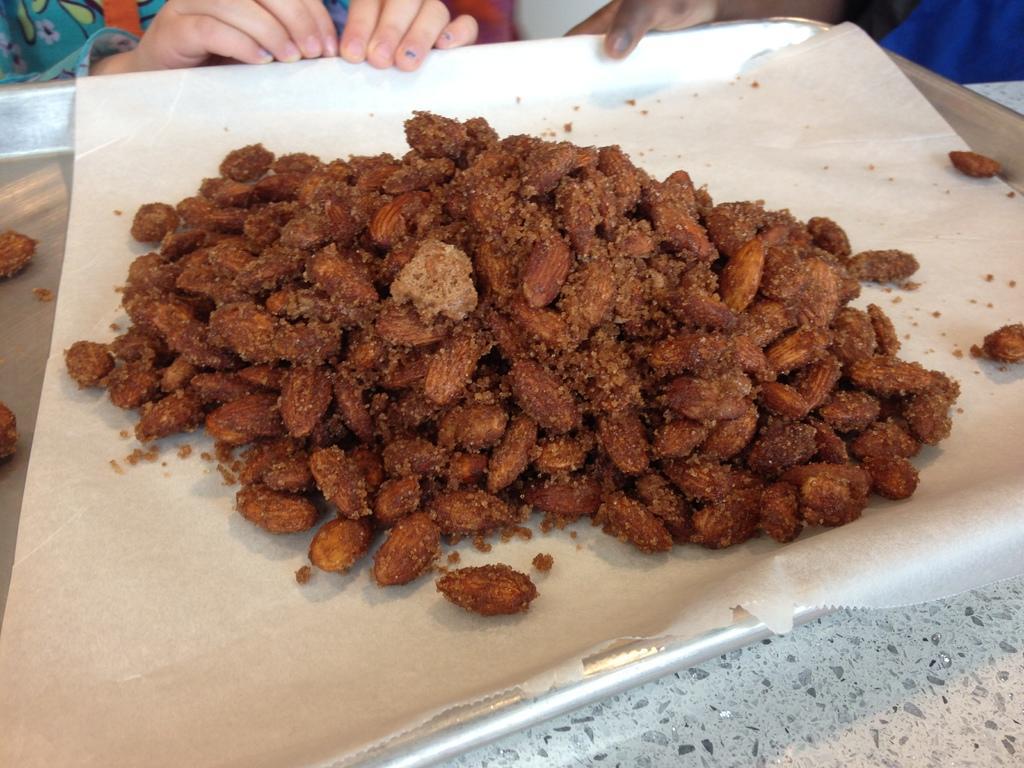Describe this image in one or two sentences. In the image we can see a paper, on the paper there are roasted almonds, this is a tray. We can even see there are people wearing clothes. 